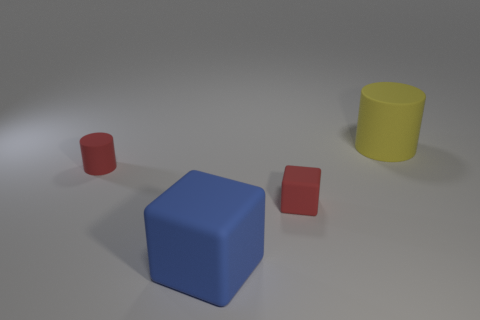Add 1 large matte cubes. How many objects exist? 5 Add 4 tiny purple metallic things. How many tiny purple metallic things exist? 4 Subtract 0 green blocks. How many objects are left? 4 Subtract all large blue blocks. Subtract all cyan cubes. How many objects are left? 3 Add 3 big yellow things. How many big yellow things are left? 4 